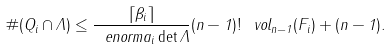Convert formula to latex. <formula><loc_0><loc_0><loc_500><loc_500>\# ( Q _ { i } \cap \Lambda ) \leq \frac { \lceil \beta _ { i } \rceil } { \ e n o r m { a _ { i } } \det \Lambda } ( n - 1 ) ! \, \ v o l _ { n - 1 } ( F _ { i } ) + ( n - 1 ) .</formula> 